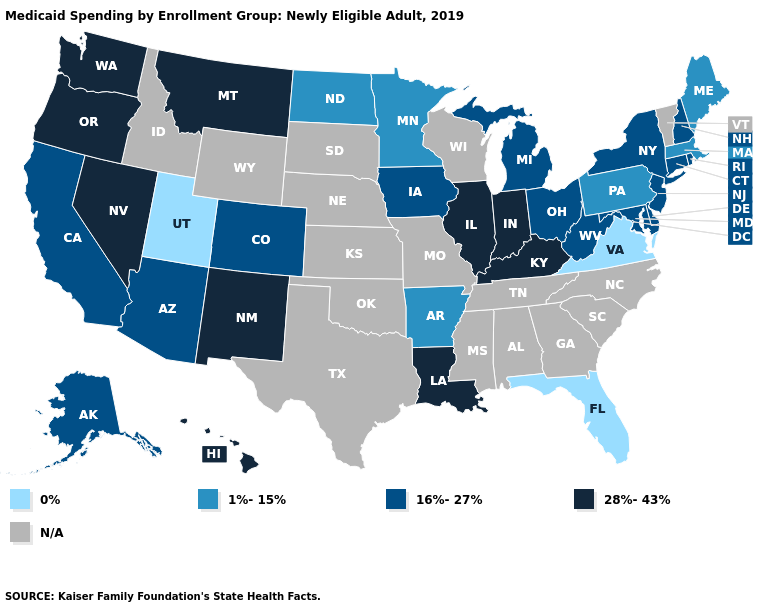What is the lowest value in states that border Minnesota?
Write a very short answer. 1%-15%. Which states have the lowest value in the Northeast?
Keep it brief. Maine, Massachusetts, Pennsylvania. Does Virginia have the lowest value in the USA?
Quick response, please. Yes. Among the states that border Indiana , does Michigan have the highest value?
Give a very brief answer. No. What is the value of Nebraska?
Be succinct. N/A. What is the lowest value in the USA?
Keep it brief. 0%. Name the states that have a value in the range N/A?
Be succinct. Alabama, Georgia, Idaho, Kansas, Mississippi, Missouri, Nebraska, North Carolina, Oklahoma, South Carolina, South Dakota, Tennessee, Texas, Vermont, Wisconsin, Wyoming. Among the states that border Virginia , which have the highest value?
Short answer required. Kentucky. What is the value of Wisconsin?
Be succinct. N/A. What is the value of Montana?
Quick response, please. 28%-43%. Is the legend a continuous bar?
Short answer required. No. Does the first symbol in the legend represent the smallest category?
Keep it brief. Yes. Which states hav the highest value in the Northeast?
Keep it brief. Connecticut, New Hampshire, New Jersey, New York, Rhode Island. Which states have the lowest value in the West?
Quick response, please. Utah. What is the lowest value in the USA?
Quick response, please. 0%. 